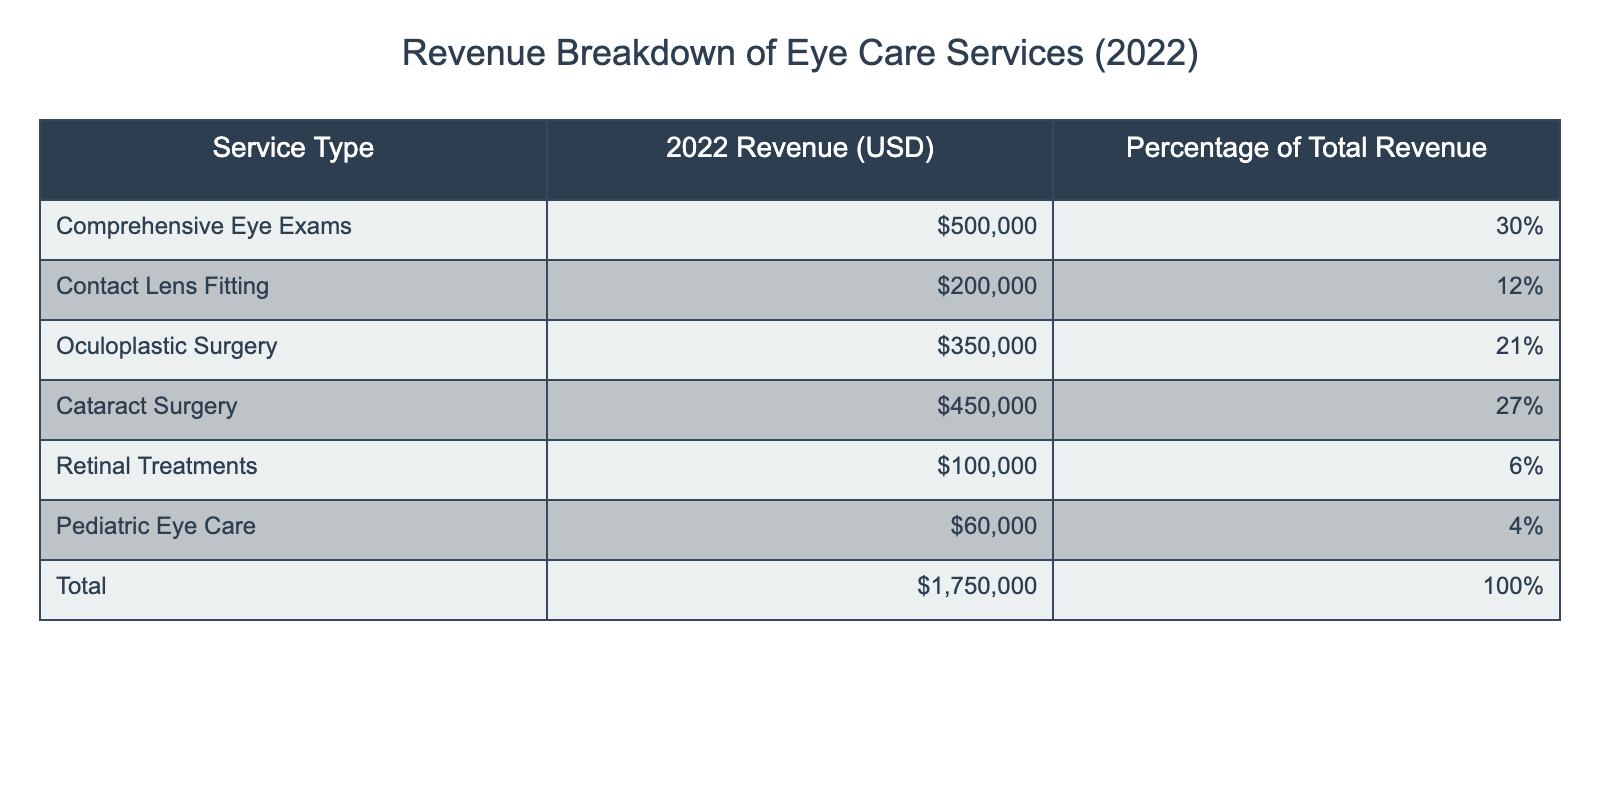What is the total revenue generated from Comprehensive Eye Exams? The table shows that the revenue generated from Comprehensive Eye Exams is listed as 500,000 USD.
Answer: 500,000 USD What percentage of the total revenue does Pediatric Eye Care represent? According to the table, Pediatric Eye Care constitutes 4% of the total revenue.
Answer: 4% Which service type generated the highest revenue in 2022? The Oculoplastic Surgery service type generated the highest revenue at 350,000 USD, which is the largest value in the revenue column.
Answer: Oculoplastic Surgery What is the total revenue generated from surgeries (Oculoplastic Surgery and Cataract Surgery)? The revenue from Oculoplastic Surgery is 350,000 USD and from Cataract Surgery is 450,000 USD. Adding these together (350,000 + 450,000) gives a total of 800,000 USD.
Answer: 800,000 USD Is it true that Retinal Treatments generated more revenue than Pediatric Eye Care? The revenue for Retinal Treatments is 100,000 USD, while Pediatric Eye Care generated 60,000 USD. Therefore, it is true that Retinal Treatments generated more revenue.
Answer: Yes What is the combined percentage of revenue for Comprehensive Eye Exams and Contact Lens Fitting? Comprehensive Eye Exams is 30% and Contact Lens Fitting is 12%. Adding these percentages (30% + 12%) gives a combined percentage of 42%.
Answer: 42% What is the difference in revenue between Cataract Surgery and Contact Lens Fitting? Cataract Surgery generated 450,000 USD and Contact Lens Fitting generated 200,000 USD. The difference is calculated as 450,000 - 200,000 = 250,000 USD.
Answer: 250,000 USD If we sum up the revenues from Retinal Treatments and Pediatric Eye Care, what is the total? The revenue from Retinal Treatments is 100,000 USD and from Pediatric Eye Care is 60,000 USD. Summing these gives 100,000 + 60,000 = 160,000 USD.
Answer: 160,000 USD Which two service types combined generated less than 200,000 USD? The table shows that both Pediatric Eye Care (60,000 USD) and Retinal Treatments (100,000 USD) combined generate 160,000 USD, which is less than 200,000 USD.
Answer: Pediatric Eye Care and Retinal Treatments 